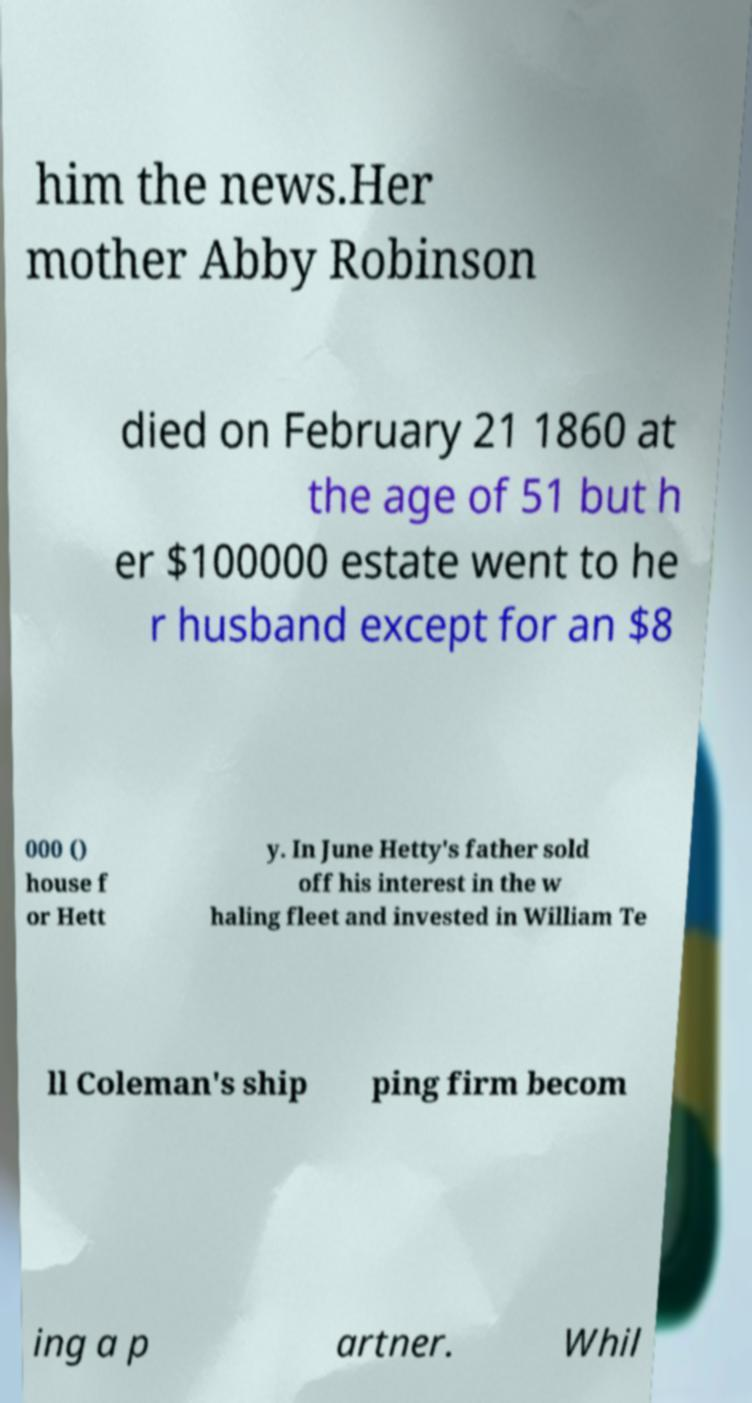Please identify and transcribe the text found in this image. him the news.Her mother Abby Robinson died on February 21 1860 at the age of 51 but h er $100000 estate went to he r husband except for an $8 000 () house f or Hett y. In June Hetty's father sold off his interest in the w haling fleet and invested in William Te ll Coleman's ship ping firm becom ing a p artner. Whil 